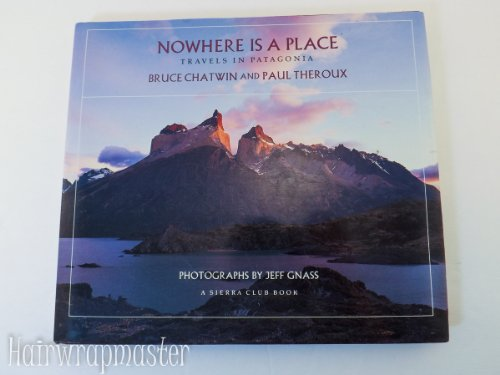Is this book related to Mystery, Thriller & Suspense? No, this book is not related to the Mystery, Thriller & Suspense genres; it is a travel narrative that delves into the geographical and cultural fabric of Patagonia. 